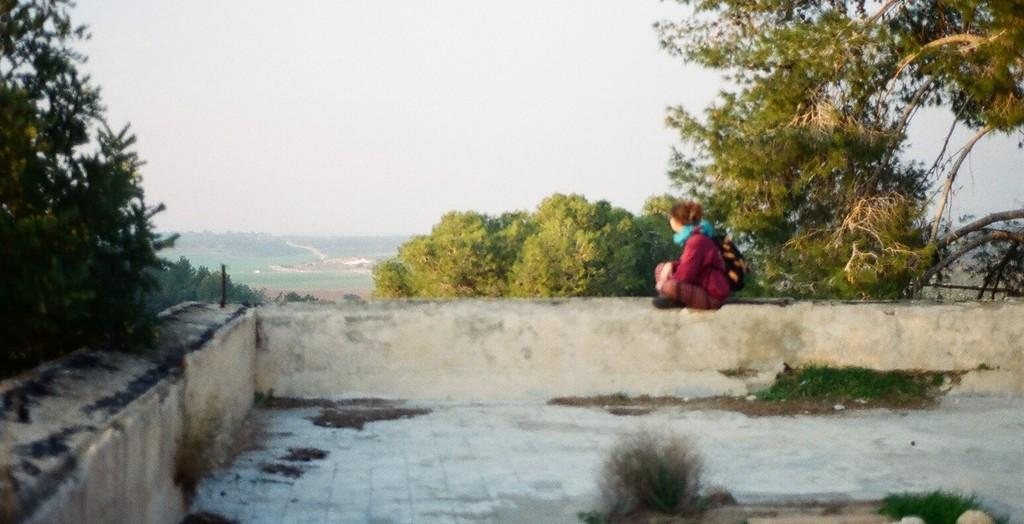Who is the main subject in the image? There is a girl in the image. What is the girl doing in the image? The girl is sitting on a wall. What can be seen in the background of the image? There are trees visible in the background of the image. What type of ground is visible in the image? There is grass on the ground in the image. What type of nut is the girl holding in the image? There is no nut present in the image; the girl is sitting on a wall with no visible objects in her hands. 